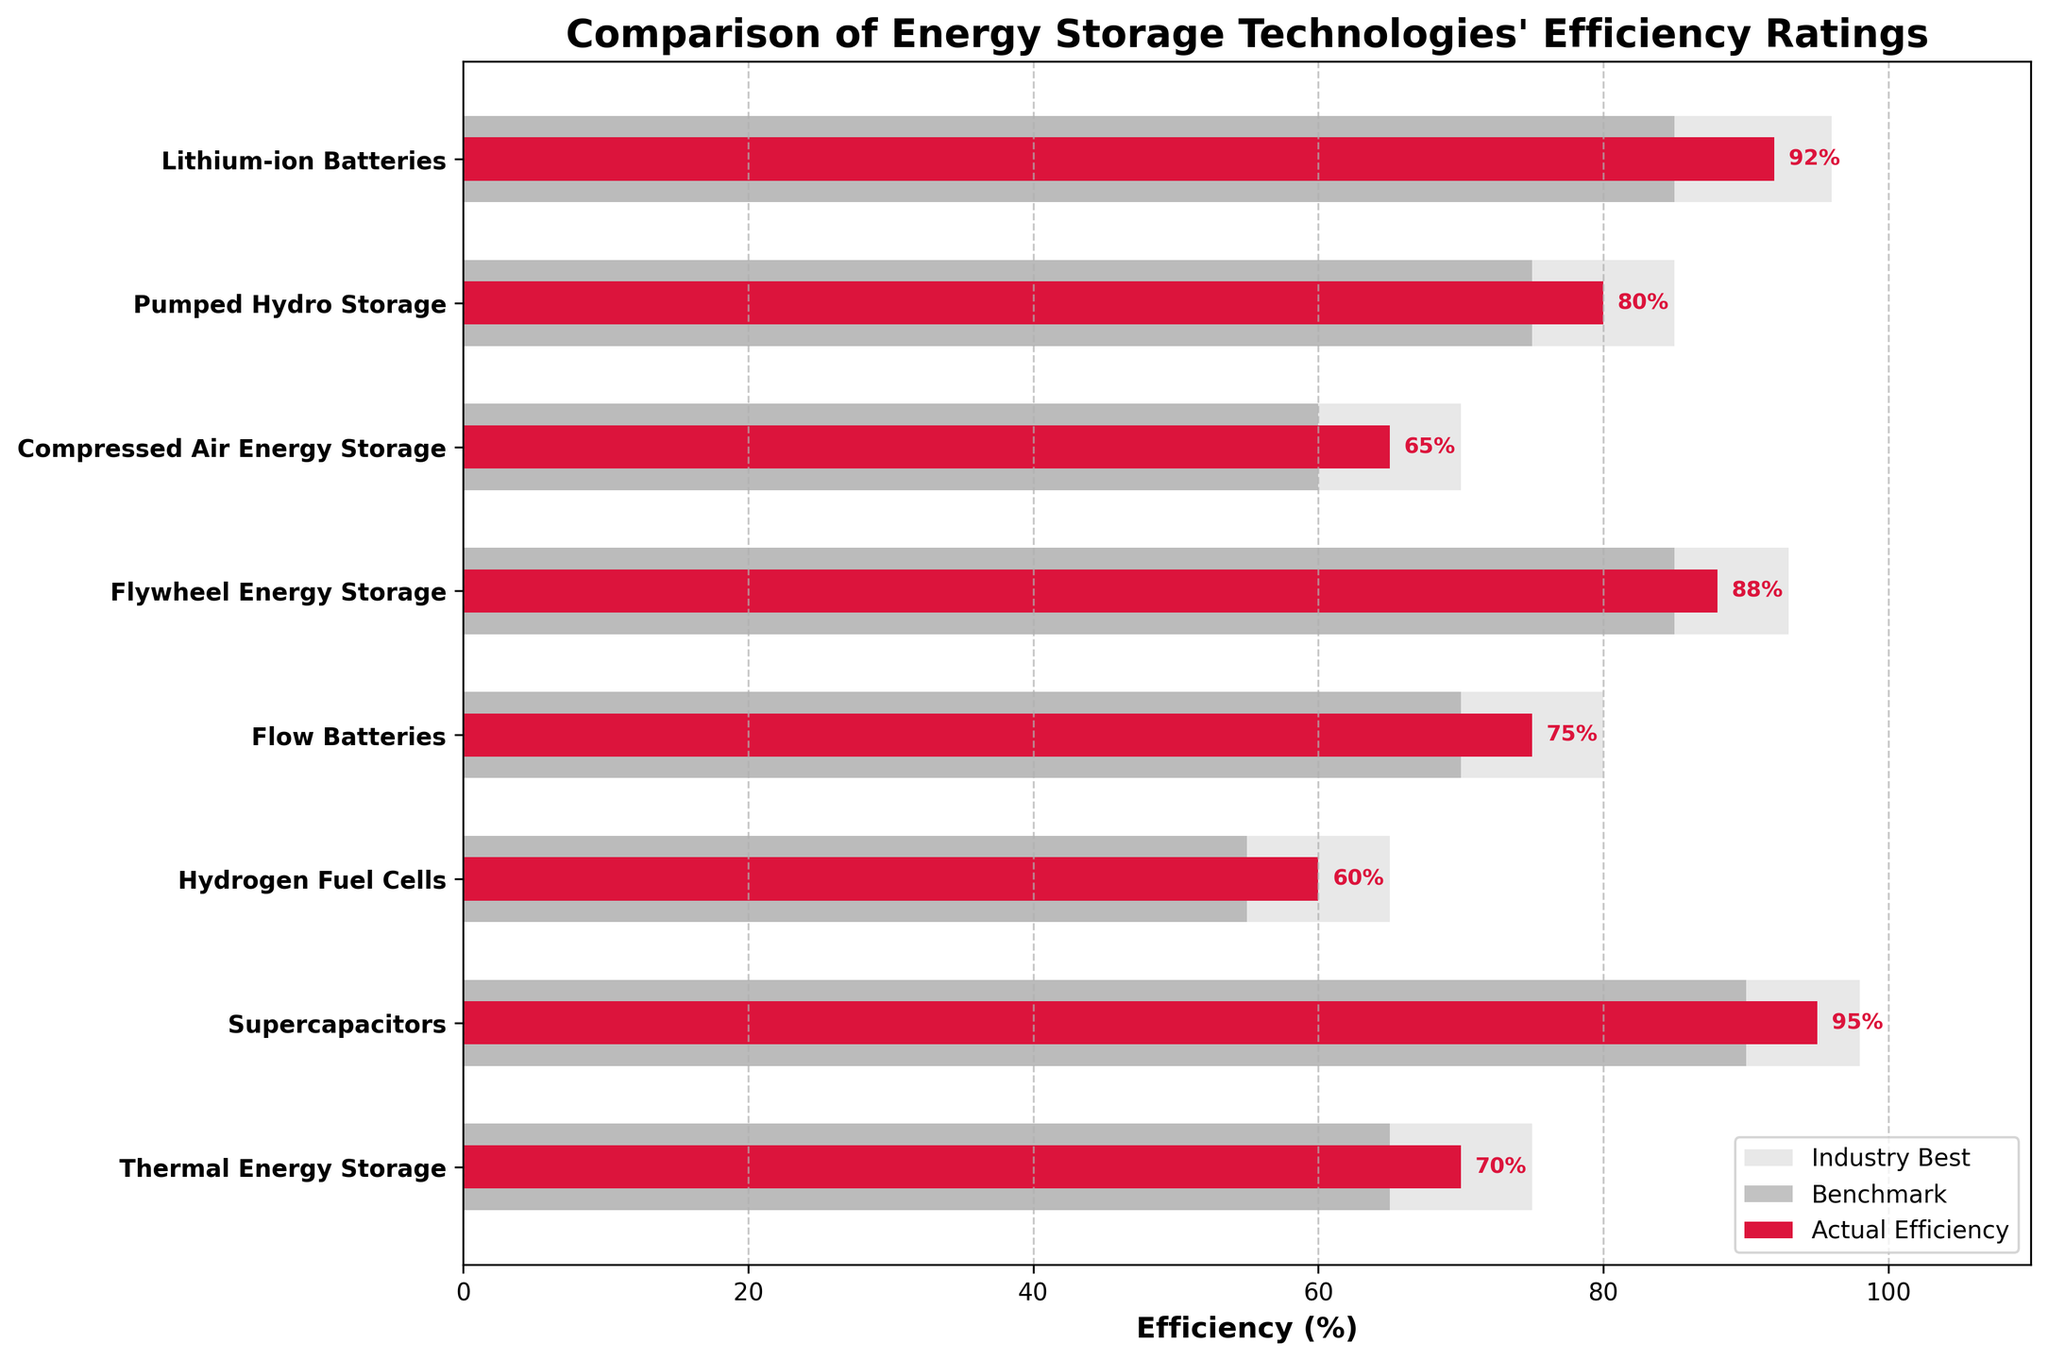What is the title of the figure? The title of the figure is displayed at the top, representing the main topic of the chart.
Answer: Comparison of Energy Storage Technologies' Efficiency Ratings How many energy storage technologies are compared in the chart? Count the number of unique labels on the y-axis to determine how many technologies are shown.
Answer: 8 What color represents the actual efficiency in the bar chart? Identify the color of the partial bars that are distinctly shorter and marked separately from the benchmarks and industry best.
Answer: Crimson Which technology has the highest actual efficiency rating? Compare the lengths of all the crimson bars representative of actual efficiency and identify the longest one.
Answer: Supercapacitors Which technology's actual efficiency rating is closest to its industry best? Calculate the difference between actual efficiency and industry best for each technology and identify the minimum value.
Answer: Lithium-ion Batteries Are there any technologies where the actual efficiency falls below the benchmark? Compare the length of the crimson bars (actual efficiency) with the dark grey bars (benchmark) to see if any actual efficiencies are less than the benchmark.
Answer: No What is the difference in actual efficiency between Flywheel Energy Storage and Thermal Energy Storage? Subtract the actual efficiency percentage of Thermal Energy Storage from that of Flywheel Energy Storage (Flywheel 88% - Thermal 70%).
Answer: 18% List the technologies where the actual efficiency is above 85%. Identify the technologies where the crimson bar (actual efficiency) exceeds the 85% mark on the x-axis.
Answer: Lithium-ion Batteries, Flywheel Energy Storage, Supercapacitors Which technology has the largest gap between industry best and benchmark efficiency? For each technology, subtract the benchmark efficiency from the industry best efficiency and identify the largest value.
Answer: Supercapacitors What is the average benchmark efficiency of all the technologies combined? Sum all benchmark efficiencies and divide by the number of technologies (85 + 75 + 60 + 85 + 70 + 55 + 90 + 65)/8.
Answer: 73.125% 